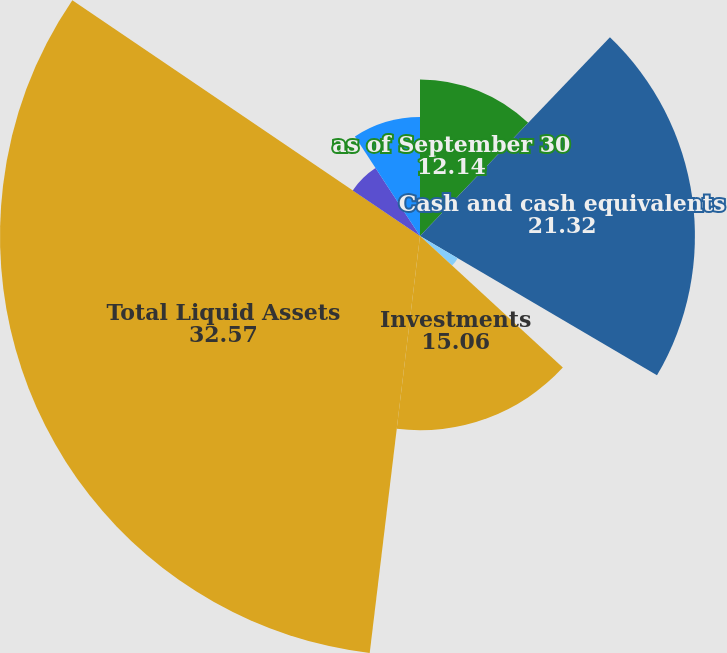Convert chart to OTSL. <chart><loc_0><loc_0><loc_500><loc_500><pie_chart><fcel>as of September 30<fcel>Cash and cash equivalents<fcel>Receivables<fcel>Investments<fcel>Total Liquid Assets<fcel>Senior notes<fcel>Total Debt<nl><fcel>12.14%<fcel>21.32%<fcel>3.39%<fcel>15.06%<fcel>32.57%<fcel>6.3%<fcel>9.22%<nl></chart> 